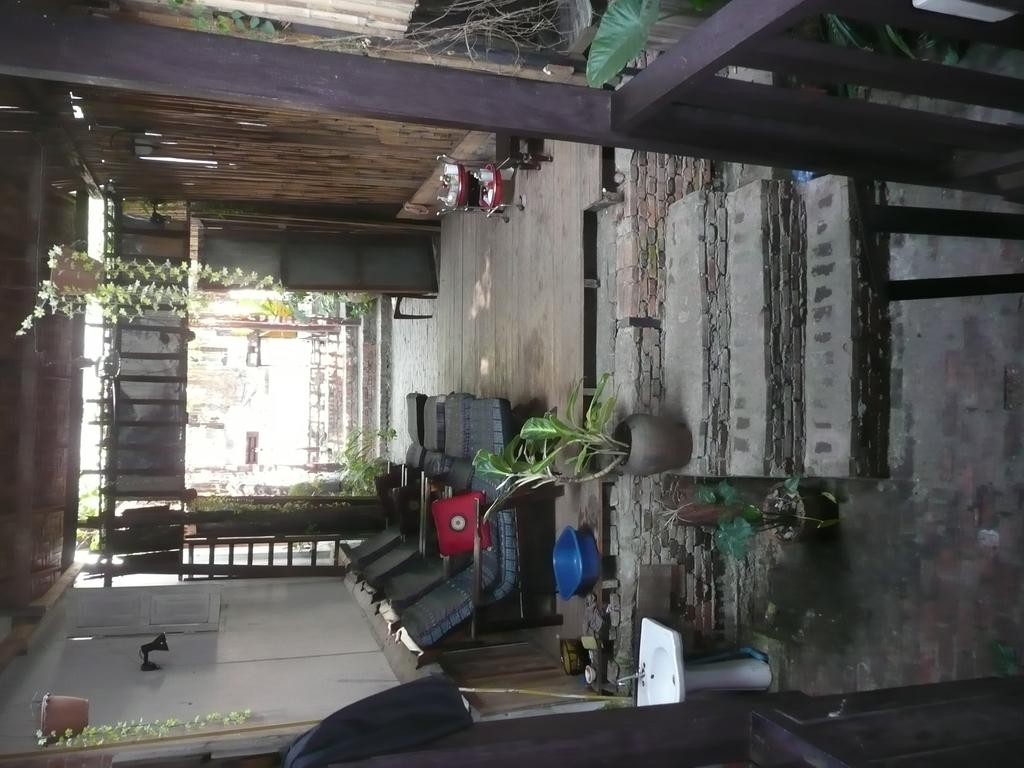What is the main structure in the center of the image? There is a wall in the center of the image. What type of objects can be seen near the wall? There are pots with plants and relaxing chairs in the image. Can you describe the color of the basket in the image? There is a blue color basket in the image. What is the purpose of the sink and tap in the image? The sink and tap are likely used for washing or cleaning purposes. What architectural feature is present in the image? There is a staircase in the image. Are there any other objects visible in the image? Yes, there are a few other objects in the image. Can you see any icicles hanging from the wall in the image? No, there are no icicles present in the image. Is there a boat visible in the image? No, there is no boat present in the image. 